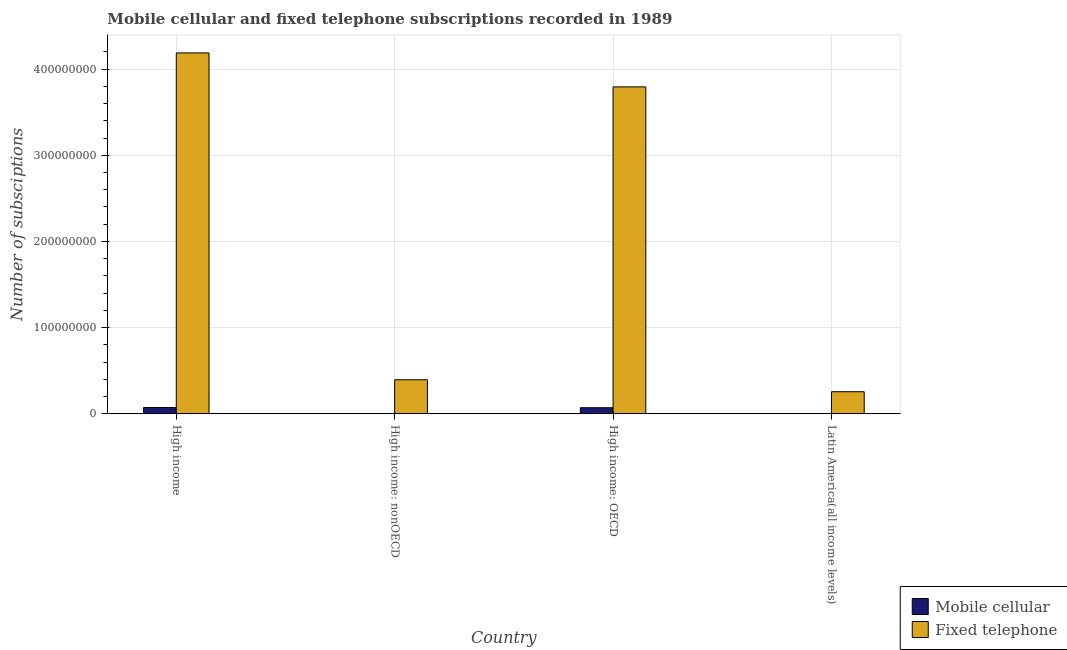How many different coloured bars are there?
Provide a succinct answer. 2. Are the number of bars per tick equal to the number of legend labels?
Offer a terse response. Yes. What is the label of the 4th group of bars from the left?
Provide a succinct answer. Latin America(all income levels). In how many cases, is the number of bars for a given country not equal to the number of legend labels?
Provide a succinct answer. 0. What is the number of fixed telephone subscriptions in High income?
Your answer should be very brief. 4.19e+08. Across all countries, what is the maximum number of fixed telephone subscriptions?
Offer a terse response. 4.19e+08. Across all countries, what is the minimum number of fixed telephone subscriptions?
Offer a very short reply. 2.55e+07. In which country was the number of mobile cellular subscriptions maximum?
Your response must be concise. High income. In which country was the number of mobile cellular subscriptions minimum?
Offer a very short reply. Latin America(all income levels). What is the total number of fixed telephone subscriptions in the graph?
Provide a succinct answer. 8.63e+08. What is the difference between the number of fixed telephone subscriptions in High income: OECD and that in Latin America(all income levels)?
Your answer should be compact. 3.54e+08. What is the difference between the number of fixed telephone subscriptions in High income: OECD and the number of mobile cellular subscriptions in High income?
Keep it short and to the point. 3.72e+08. What is the average number of fixed telephone subscriptions per country?
Provide a succinct answer. 2.16e+08. What is the difference between the number of mobile cellular subscriptions and number of fixed telephone subscriptions in Latin America(all income levels)?
Make the answer very short. -2.55e+07. What is the ratio of the number of mobile cellular subscriptions in High income to that in High income: nonOECD?
Offer a very short reply. 31.7. Is the difference between the number of fixed telephone subscriptions in High income and High income: nonOECD greater than the difference between the number of mobile cellular subscriptions in High income and High income: nonOECD?
Provide a succinct answer. Yes. What is the difference between the highest and the second highest number of mobile cellular subscriptions?
Your answer should be very brief. 2.28e+05. What is the difference between the highest and the lowest number of mobile cellular subscriptions?
Keep it short and to the point. 7.19e+06. In how many countries, is the number of fixed telephone subscriptions greater than the average number of fixed telephone subscriptions taken over all countries?
Make the answer very short. 2. What does the 2nd bar from the left in High income: nonOECD represents?
Provide a succinct answer. Fixed telephone. What does the 1st bar from the right in Latin America(all income levels) represents?
Offer a terse response. Fixed telephone. How many bars are there?
Provide a short and direct response. 8. Are all the bars in the graph horizontal?
Keep it short and to the point. No. Does the graph contain grids?
Your answer should be very brief. Yes. Where does the legend appear in the graph?
Offer a terse response. Bottom right. How many legend labels are there?
Keep it short and to the point. 2. What is the title of the graph?
Provide a succinct answer. Mobile cellular and fixed telephone subscriptions recorded in 1989. Does "Methane emissions" appear as one of the legend labels in the graph?
Your response must be concise. No. What is the label or title of the Y-axis?
Provide a short and direct response. Number of subsciptions. What is the Number of subsciptions of Mobile cellular in High income?
Ensure brevity in your answer.  7.22e+06. What is the Number of subsciptions of Fixed telephone in High income?
Provide a short and direct response. 4.19e+08. What is the Number of subsciptions of Mobile cellular in High income: nonOECD?
Keep it short and to the point. 2.28e+05. What is the Number of subsciptions of Fixed telephone in High income: nonOECD?
Ensure brevity in your answer.  3.94e+07. What is the Number of subsciptions in Mobile cellular in High income: OECD?
Your answer should be compact. 6.99e+06. What is the Number of subsciptions in Fixed telephone in High income: OECD?
Make the answer very short. 3.79e+08. What is the Number of subsciptions in Mobile cellular in Latin America(all income levels)?
Keep it short and to the point. 3.10e+04. What is the Number of subsciptions of Fixed telephone in Latin America(all income levels)?
Your response must be concise. 2.55e+07. Across all countries, what is the maximum Number of subsciptions of Mobile cellular?
Provide a succinct answer. 7.22e+06. Across all countries, what is the maximum Number of subsciptions in Fixed telephone?
Provide a succinct answer. 4.19e+08. Across all countries, what is the minimum Number of subsciptions in Mobile cellular?
Offer a terse response. 3.10e+04. Across all countries, what is the minimum Number of subsciptions of Fixed telephone?
Give a very brief answer. 2.55e+07. What is the total Number of subsciptions of Mobile cellular in the graph?
Your response must be concise. 1.45e+07. What is the total Number of subsciptions in Fixed telephone in the graph?
Ensure brevity in your answer.  8.63e+08. What is the difference between the Number of subsciptions of Mobile cellular in High income and that in High income: nonOECD?
Keep it short and to the point. 6.99e+06. What is the difference between the Number of subsciptions in Fixed telephone in High income and that in High income: nonOECD?
Your response must be concise. 3.79e+08. What is the difference between the Number of subsciptions in Mobile cellular in High income and that in High income: OECD?
Keep it short and to the point. 2.28e+05. What is the difference between the Number of subsciptions in Fixed telephone in High income and that in High income: OECD?
Offer a terse response. 3.94e+07. What is the difference between the Number of subsciptions of Mobile cellular in High income and that in Latin America(all income levels)?
Your response must be concise. 7.19e+06. What is the difference between the Number of subsciptions of Fixed telephone in High income and that in Latin America(all income levels)?
Ensure brevity in your answer.  3.93e+08. What is the difference between the Number of subsciptions of Mobile cellular in High income: nonOECD and that in High income: OECD?
Make the answer very short. -6.76e+06. What is the difference between the Number of subsciptions of Fixed telephone in High income: nonOECD and that in High income: OECD?
Keep it short and to the point. -3.40e+08. What is the difference between the Number of subsciptions of Mobile cellular in High income: nonOECD and that in Latin America(all income levels)?
Give a very brief answer. 1.97e+05. What is the difference between the Number of subsciptions in Fixed telephone in High income: nonOECD and that in Latin America(all income levels)?
Your response must be concise. 1.39e+07. What is the difference between the Number of subsciptions of Mobile cellular in High income: OECD and that in Latin America(all income levels)?
Ensure brevity in your answer.  6.96e+06. What is the difference between the Number of subsciptions of Fixed telephone in High income: OECD and that in Latin America(all income levels)?
Provide a short and direct response. 3.54e+08. What is the difference between the Number of subsciptions in Mobile cellular in High income and the Number of subsciptions in Fixed telephone in High income: nonOECD?
Ensure brevity in your answer.  -3.22e+07. What is the difference between the Number of subsciptions of Mobile cellular in High income and the Number of subsciptions of Fixed telephone in High income: OECD?
Your response must be concise. -3.72e+08. What is the difference between the Number of subsciptions of Mobile cellular in High income and the Number of subsciptions of Fixed telephone in Latin America(all income levels)?
Offer a very short reply. -1.83e+07. What is the difference between the Number of subsciptions of Mobile cellular in High income: nonOECD and the Number of subsciptions of Fixed telephone in High income: OECD?
Ensure brevity in your answer.  -3.79e+08. What is the difference between the Number of subsciptions in Mobile cellular in High income: nonOECD and the Number of subsciptions in Fixed telephone in Latin America(all income levels)?
Your answer should be compact. -2.53e+07. What is the difference between the Number of subsciptions in Mobile cellular in High income: OECD and the Number of subsciptions in Fixed telephone in Latin America(all income levels)?
Offer a terse response. -1.86e+07. What is the average Number of subsciptions of Mobile cellular per country?
Keep it short and to the point. 3.62e+06. What is the average Number of subsciptions of Fixed telephone per country?
Provide a succinct answer. 2.16e+08. What is the difference between the Number of subsciptions in Mobile cellular and Number of subsciptions in Fixed telephone in High income?
Your answer should be very brief. -4.12e+08. What is the difference between the Number of subsciptions in Mobile cellular and Number of subsciptions in Fixed telephone in High income: nonOECD?
Your answer should be compact. -3.92e+07. What is the difference between the Number of subsciptions of Mobile cellular and Number of subsciptions of Fixed telephone in High income: OECD?
Offer a terse response. -3.72e+08. What is the difference between the Number of subsciptions in Mobile cellular and Number of subsciptions in Fixed telephone in Latin America(all income levels)?
Give a very brief answer. -2.55e+07. What is the ratio of the Number of subsciptions of Mobile cellular in High income to that in High income: nonOECD?
Keep it short and to the point. 31.7. What is the ratio of the Number of subsciptions in Fixed telephone in High income to that in High income: nonOECD?
Your answer should be compact. 10.62. What is the ratio of the Number of subsciptions of Mobile cellular in High income to that in High income: OECD?
Offer a very short reply. 1.03. What is the ratio of the Number of subsciptions in Fixed telephone in High income to that in High income: OECD?
Provide a short and direct response. 1.1. What is the ratio of the Number of subsciptions in Mobile cellular in High income to that in Latin America(all income levels)?
Make the answer very short. 233.05. What is the ratio of the Number of subsciptions in Fixed telephone in High income to that in Latin America(all income levels)?
Provide a succinct answer. 16.4. What is the ratio of the Number of subsciptions in Mobile cellular in High income: nonOECD to that in High income: OECD?
Keep it short and to the point. 0.03. What is the ratio of the Number of subsciptions of Fixed telephone in High income: nonOECD to that in High income: OECD?
Ensure brevity in your answer.  0.1. What is the ratio of the Number of subsciptions in Mobile cellular in High income: nonOECD to that in Latin America(all income levels)?
Provide a short and direct response. 7.35. What is the ratio of the Number of subsciptions of Fixed telephone in High income: nonOECD to that in Latin America(all income levels)?
Your answer should be very brief. 1.54. What is the ratio of the Number of subsciptions in Mobile cellular in High income: OECD to that in Latin America(all income levels)?
Offer a very short reply. 225.7. What is the ratio of the Number of subsciptions in Fixed telephone in High income: OECD to that in Latin America(all income levels)?
Provide a short and direct response. 14.85. What is the difference between the highest and the second highest Number of subsciptions in Mobile cellular?
Provide a succinct answer. 2.28e+05. What is the difference between the highest and the second highest Number of subsciptions of Fixed telephone?
Give a very brief answer. 3.94e+07. What is the difference between the highest and the lowest Number of subsciptions of Mobile cellular?
Your answer should be very brief. 7.19e+06. What is the difference between the highest and the lowest Number of subsciptions in Fixed telephone?
Offer a very short reply. 3.93e+08. 